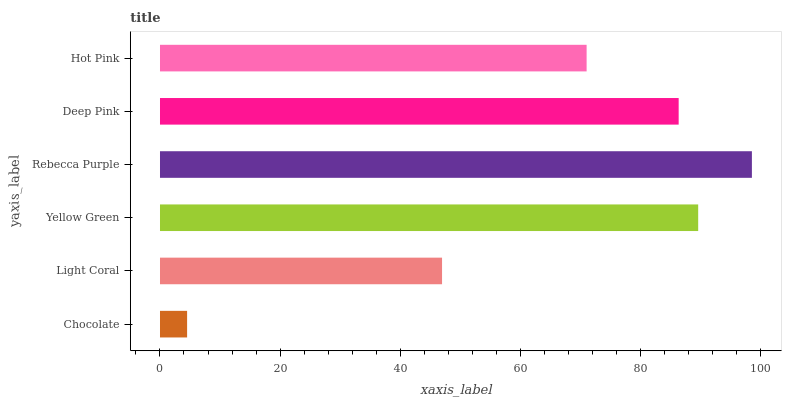Is Chocolate the minimum?
Answer yes or no. Yes. Is Rebecca Purple the maximum?
Answer yes or no. Yes. Is Light Coral the minimum?
Answer yes or no. No. Is Light Coral the maximum?
Answer yes or no. No. Is Light Coral greater than Chocolate?
Answer yes or no. Yes. Is Chocolate less than Light Coral?
Answer yes or no. Yes. Is Chocolate greater than Light Coral?
Answer yes or no. No. Is Light Coral less than Chocolate?
Answer yes or no. No. Is Deep Pink the high median?
Answer yes or no. Yes. Is Hot Pink the low median?
Answer yes or no. Yes. Is Yellow Green the high median?
Answer yes or no. No. Is Light Coral the low median?
Answer yes or no. No. 